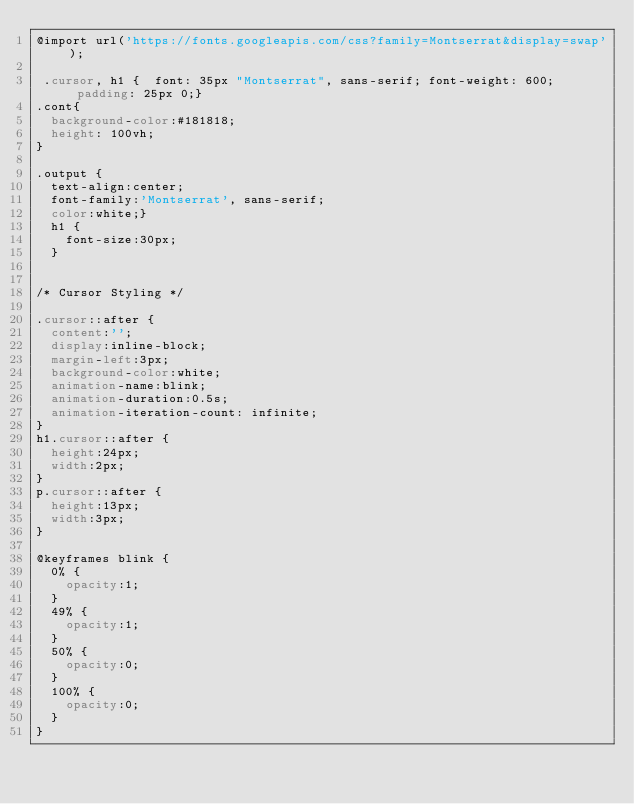Convert code to text. <code><loc_0><loc_0><loc_500><loc_500><_CSS_>@import url('https://fonts.googleapis.com/css?family=Montserrat&display=swap');

 .cursor, h1 {  font: 35px "Montserrat", sans-serif; font-weight: 600; padding: 25px 0;}
.cont{
  background-color:#181818;
  height: 100vh;
}

.output {
  text-align:center;
  font-family:'Montserrat', sans-serif;
  color:white;}
  h1 {
    font-size:30px;
  }


/* Cursor Styling */

.cursor::after {
  content:'';
  display:inline-block;
  margin-left:3px;
  background-color:white;
  animation-name:blink;
  animation-duration:0.5s;
  animation-iteration-count: infinite;
}
h1.cursor::after {
  height:24px;
  width:2px;
}
p.cursor::after {
  height:13px;
  width:3px;
}

@keyframes blink {
  0% {
    opacity:1;
  }
  49% {
    opacity:1;
  }
  50% {
    opacity:0;
  }
  100% {
    opacity:0;
  }
}

</code> 